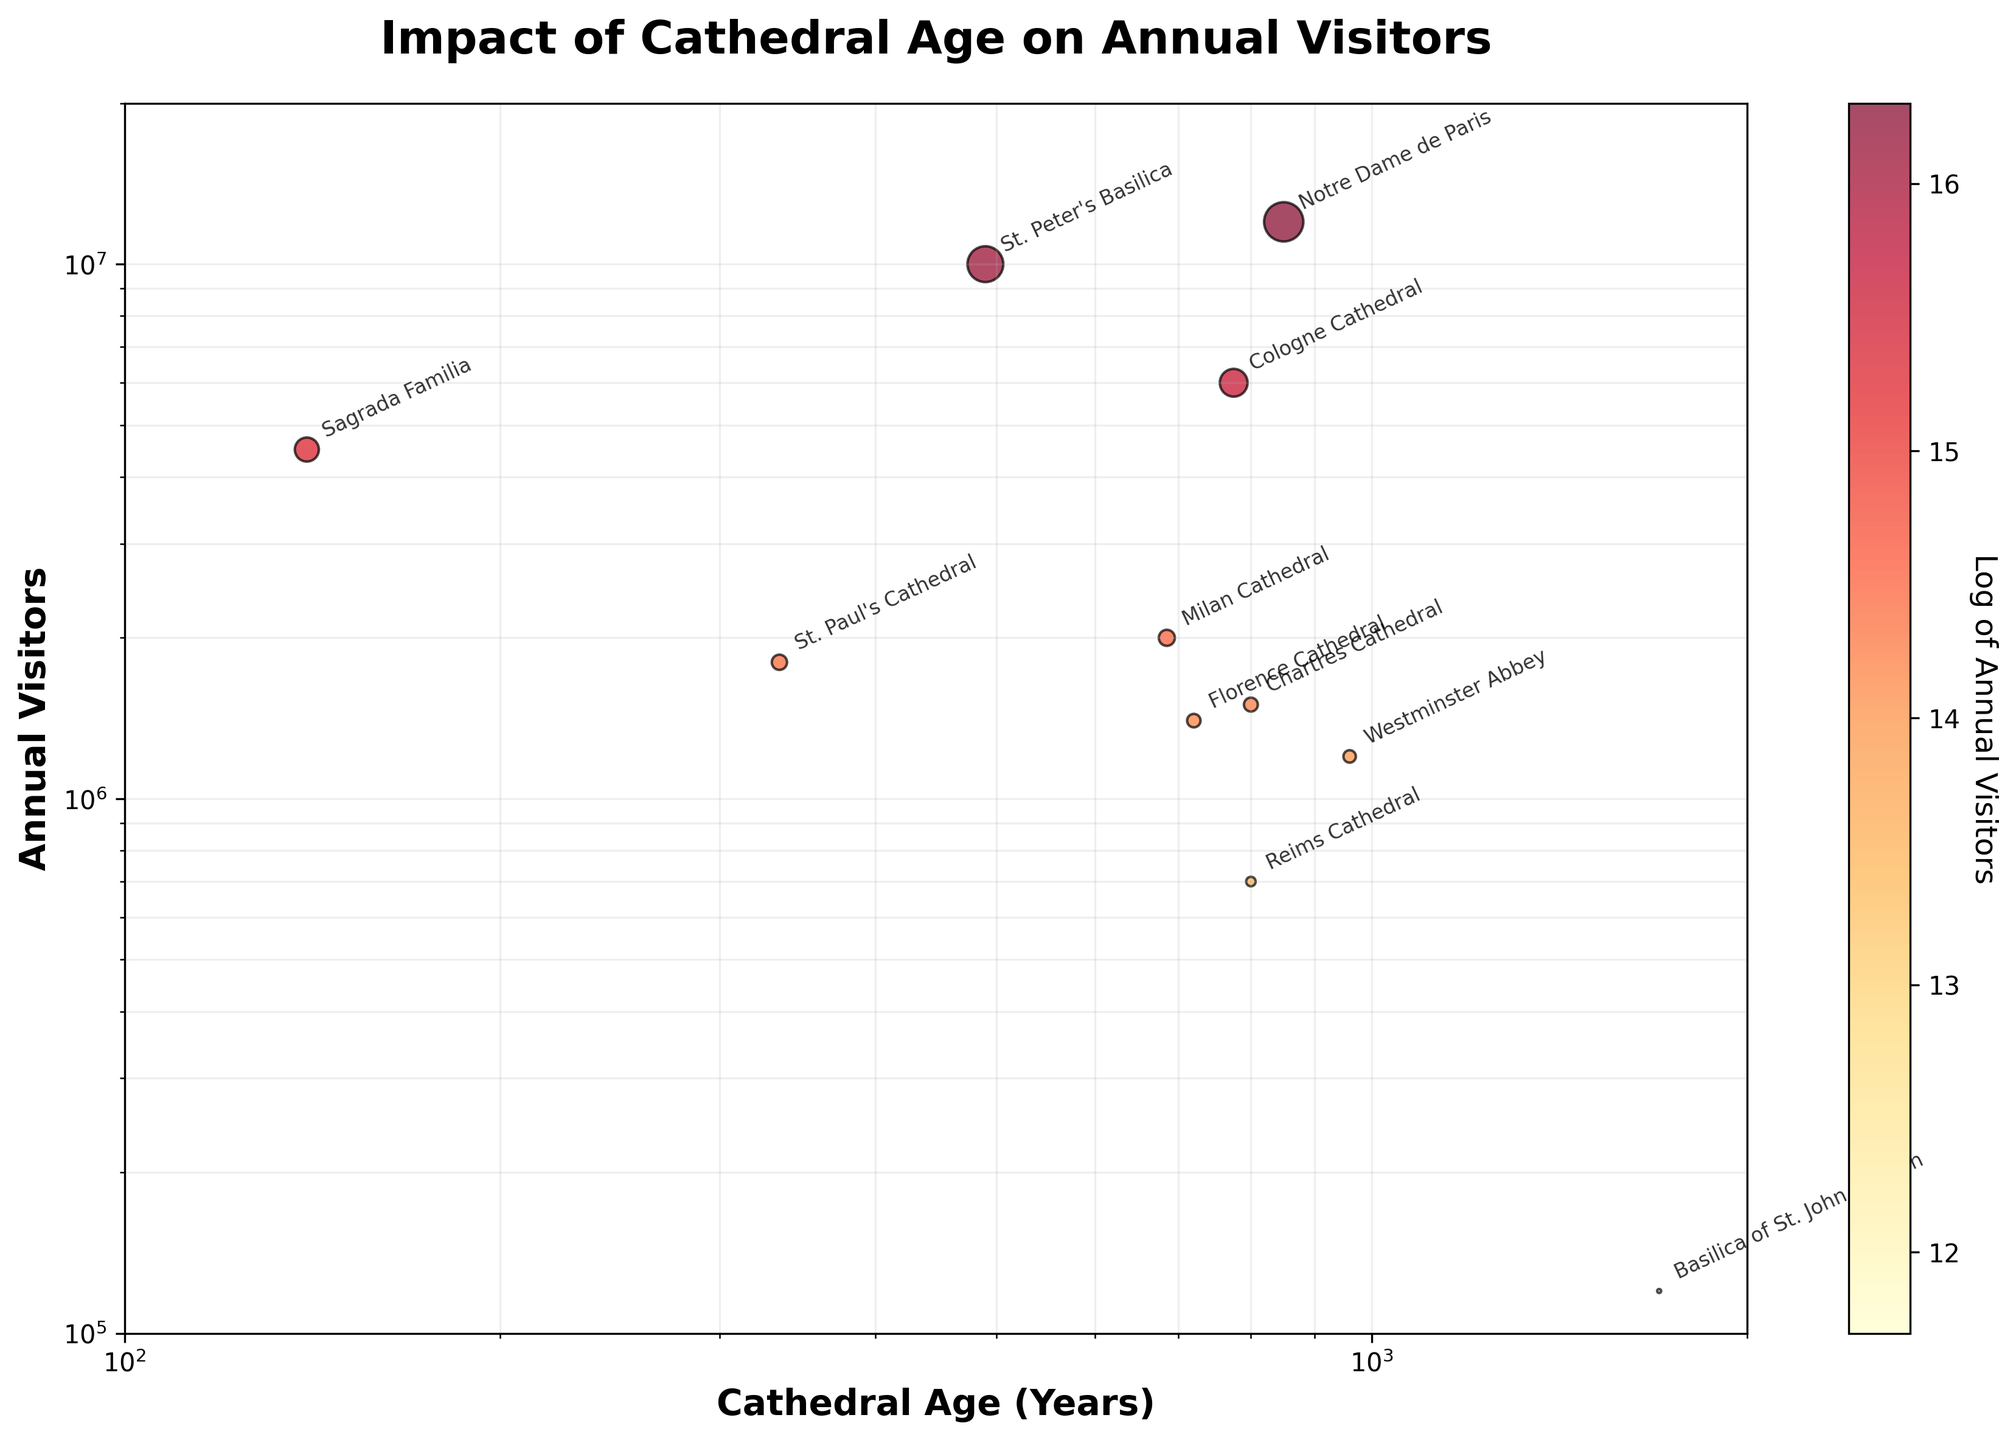What is the title of the figure? The title of the figure is typically located at the top of the chart. In this case, it says "Impact of Cathedral Age on Annual Visitors".
Answer: Impact of Cathedral Age on Annual Visitors What are the labels of the axes? The labels of the axes are identified along the x-axis and y-axis. The x-axis label is "Cathedral Age (Years)" and the y-axis label is "Annual Visitors".
Answer: Cathedral Age (Years), Annual Visitors Which cathedral attracts the most annual visitors? The data points indicate that the cathedral with the highest number of annual visitors is positioned highest on the y-axis. Notre Dame de Paris has 12,000,000 annual visitors, placing it at the top.
Answer: Notre Dame de Paris What is the age range of the cathedrals in the figure? The age range can be determined by looking at the x-axis values, which show the minimum and maximum ages of the cathedrals. The cathedrals range from 140 years (Sagrada Familia) to 1700 years (Basilica of St. John Lateran).
Answer: 140 to 1700 years Which cathedrals are older than 800 years? By locating the data points to the right of 800 years on the x-axis, we can identify the older cathedrals. These include Notre Dame de Paris, Westminster Abbey, Chartres Cathedral, Florence Cathedral, and Reims Cathedral.
Answer: Notre Dame de Paris, Westminster Abbey, Chartres Cathedral, Florence Cathedral, Reims Cathedral How does the annotation help to understand the figure? The annotations label each data point with the cathedral names, making it easier to identify which point corresponds to which cathedral without needing to cross-reference with a legend. This helps in directly comparing the cathedrals' ages and annual visitors.
Answer: Labels the cathedrals Which two cathedrals have a similar number of visitors but a significant difference in age? Identify two data points with close values on the y-axis (annual visitors) and significantly different values on the x-axis (age). Notre Dame de Paris and Cologne Cathedral both attract many visitors, but Notre Dame de Paris is 850 years old while Cologne Cathedral is 775 years old.
Answer: Notre Dame de Paris and Cologne Cathedral What is the relationship between cathedral age and annual visitors visible in the plot? Evaluate the general trend of the data points. The scatter plot shows no clear linear correlation between the age of a cathedral and the number of annual visitors, suggesting other factors may influence visitor numbers.
Answer: No clear linear correlation Explain the significance of the color gradient in the scatter plot. The color gradient indicates the logarithm of the annual visitors for each cathedral. Darker colors represent higher visitor numbers, which helps quickly identify the more popular cathedrals.
Answer: Represents log of annual visitors How does the size of the data points relate to the annual visitors? The size of the data points is proportional to the number of annual visitors. Larger circles represent cathedrals with higher visitation rates, aiding in quick visual identification of popular sites.
Answer: Proportional to annual visitors 